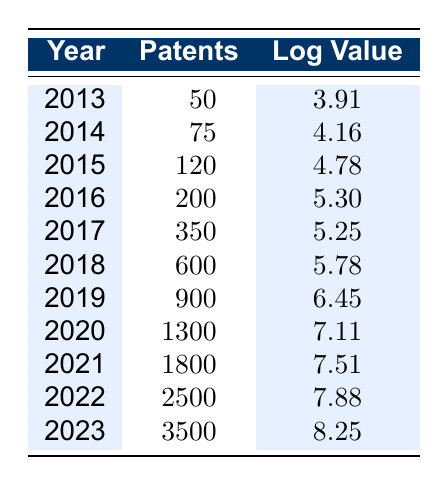What was the total number of gene editing patents in 2023? According to the table, the number of patents in the year 2023 is listed as 3500. Therefore, the total number of gene editing patents for that year is directly taken from the table.
Answer: 3500 What was the logarithmic value of gene editing patents in 2016? The logarithmic value for the year 2016 is provided in the table as 5.30. Thus, this value represents the logarithmic growth for that specific year.
Answer: 5.30 Which year saw the highest number of gene editing patents? By examining the table, we observe the highest number of patents recorded is 3500 in the year 2023. This is the maximum value when we scan through all the years listed.
Answer: 2023 What is the difference in the number of patents between 2018 and 2019? The number of patents in 2018 is 600 and in 2019 is 900. The difference is calculated as follows: 900 - 600 = 300. Hence, this is the difference in the number of patents between those two years.
Answer: 300 Is the logarithmic value for 2017 greater than that for 2018? The logarithmic value for 2017 is 5.25 and for 2018 is 5.78. Since 5.25 is less than 5.78, this statement is false.
Answer: No What was the average number of gene editing patents from 2013 to 2022? To find the average, we first sum the patents from all years in that range: 50 + 75 + 120 + 200 + 350 + 600 + 900 + 1300 + 1800 + 2500 = 6025. Since there are 10 years included, we divide by 10: 6025 / 10 = 602.5. Thus, the average number of patents is 602.5.
Answer: 602.5 What is the median number of patents over the years? First, we need to list the numbers of patents: 50, 75, 120, 200, 350, 600, 900, 1300, 1800, 2500, 3500. There are 11 data points, so the median is the middle number in the sorted list, which is the sixth value: 600.
Answer: 600 In which year did the number of patents increase from 2015 to 2016? In 2015, the number of patents is 120, and in 2016 it increases to 200. Since 200 is greater than 120, this year shows an increase in patents from the previous year.
Answer: Yes What is the growth rate of patents from 2019 to 2020? The number of patents in 2019 is 900 and in 2020 it is 1300. The growth can be calculated as: (1300 - 900) / 900 = 400 / 900 = 0.4444 or 44.44%. This shows a significant growth in that year.
Answer: 44.44% 